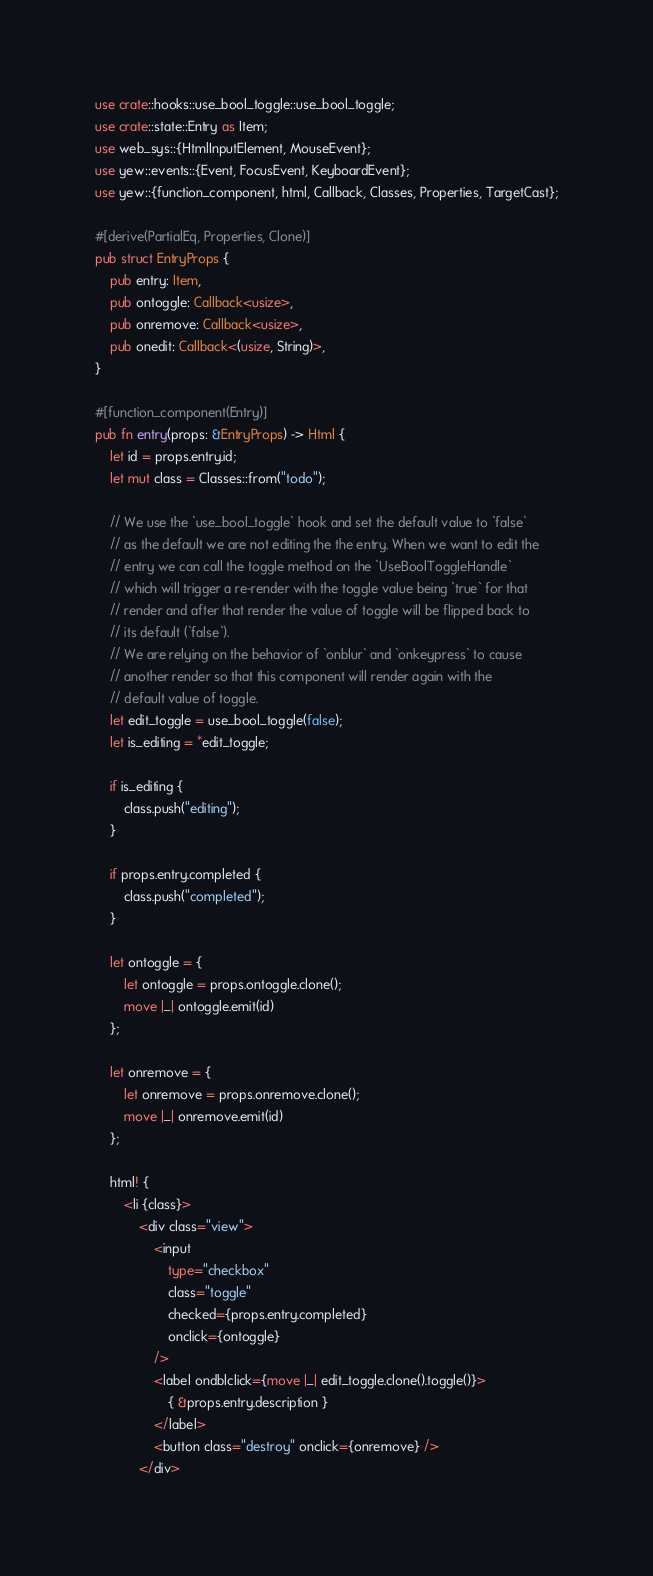<code> <loc_0><loc_0><loc_500><loc_500><_Rust_>use crate::hooks::use_bool_toggle::use_bool_toggle;
use crate::state::Entry as Item;
use web_sys::{HtmlInputElement, MouseEvent};
use yew::events::{Event, FocusEvent, KeyboardEvent};
use yew::{function_component, html, Callback, Classes, Properties, TargetCast};

#[derive(PartialEq, Properties, Clone)]
pub struct EntryProps {
    pub entry: Item,
    pub ontoggle: Callback<usize>,
    pub onremove: Callback<usize>,
    pub onedit: Callback<(usize, String)>,
}

#[function_component(Entry)]
pub fn entry(props: &EntryProps) -> Html {
    let id = props.entry.id;
    let mut class = Classes::from("todo");

    // We use the `use_bool_toggle` hook and set the default value to `false`
    // as the default we are not editing the the entry. When we want to edit the
    // entry we can call the toggle method on the `UseBoolToggleHandle`
    // which will trigger a re-render with the toggle value being `true` for that
    // render and after that render the value of toggle will be flipped back to
    // its default (`false`).
    // We are relying on the behavior of `onblur` and `onkeypress` to cause
    // another render so that this component will render again with the
    // default value of toggle.
    let edit_toggle = use_bool_toggle(false);
    let is_editing = *edit_toggle;

    if is_editing {
        class.push("editing");
    }

    if props.entry.completed {
        class.push("completed");
    }

    let ontoggle = {
        let ontoggle = props.ontoggle.clone();
        move |_| ontoggle.emit(id)
    };

    let onremove = {
        let onremove = props.onremove.clone();
        move |_| onremove.emit(id)
    };

    html! {
        <li {class}>
            <div class="view">
                <input
                    type="checkbox"
                    class="toggle"
                    checked={props.entry.completed}
                    onclick={ontoggle}
                />
                <label ondblclick={move |_| edit_toggle.clone().toggle()}>
                    { &props.entry.description }
                </label>
                <button class="destroy" onclick={onremove} />
            </div></code> 